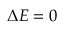Convert formula to latex. <formula><loc_0><loc_0><loc_500><loc_500>{ \Delta E } = 0</formula> 